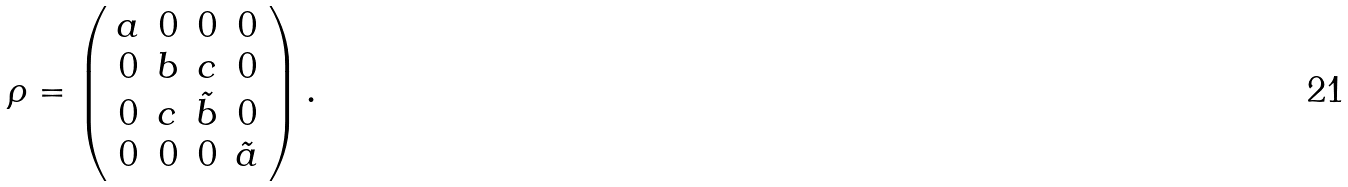Convert formula to latex. <formula><loc_0><loc_0><loc_500><loc_500>\rho = \left ( \begin{array} { c c c c } a & 0 & 0 & 0 \\ 0 & b & c & 0 \\ 0 & c & \tilde { b } & 0 \\ 0 & 0 & 0 & \tilde { a } \end{array} \right ) .</formula> 